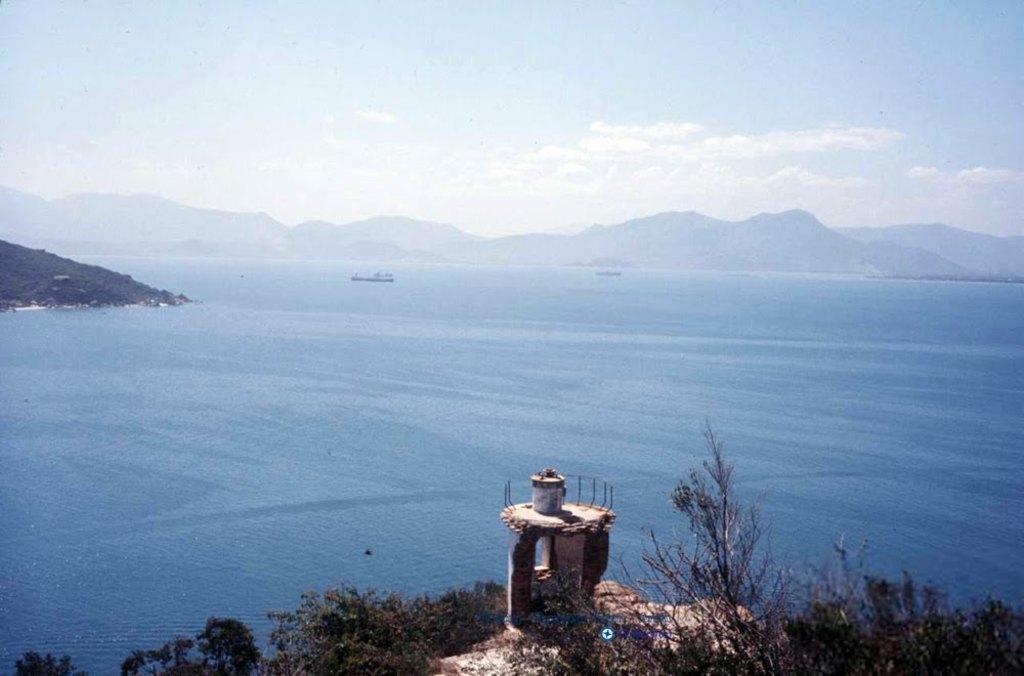In one or two sentences, can you explain what this image depicts? In the foreground of the picture we can see trees and a construction. In the middle of the picture there is a water body and a hill. In the water we can see ships. In the background there are hills. At the top there is sky. 